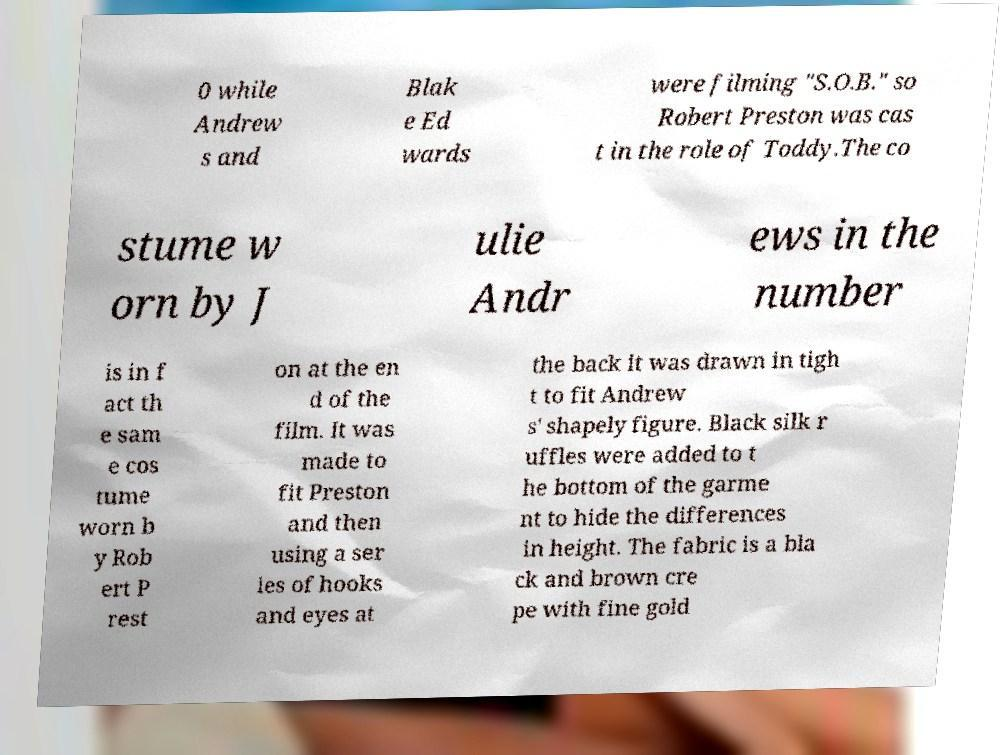Could you assist in decoding the text presented in this image and type it out clearly? 0 while Andrew s and Blak e Ed wards were filming "S.O.B." so Robert Preston was cas t in the role of Toddy.The co stume w orn by J ulie Andr ews in the number is in f act th e sam e cos tume worn b y Rob ert P rest on at the en d of the film. It was made to fit Preston and then using a ser ies of hooks and eyes at the back it was drawn in tigh t to fit Andrew s' shapely figure. Black silk r uffles were added to t he bottom of the garme nt to hide the differences in height. The fabric is a bla ck and brown cre pe with fine gold 